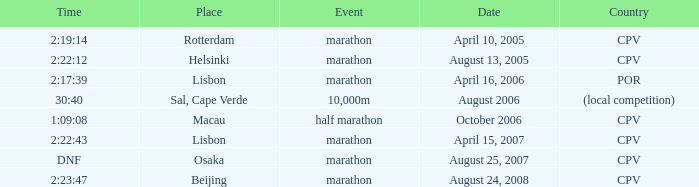Parse the full table. {'header': ['Time', 'Place', 'Event', 'Date', 'Country'], 'rows': [['2:19:14', 'Rotterdam', 'marathon', 'April 10, 2005', 'CPV'], ['2:22:12', 'Helsinki', 'marathon', 'August 13, 2005', 'CPV'], ['2:17:39', 'Lisbon', 'marathon', 'April 16, 2006', 'POR'], ['30:40', 'Sal, Cape Verde', '10,000m', 'August 2006', '(local competition)'], ['1:09:08', 'Macau', 'half marathon', 'October 2006', 'CPV'], ['2:22:43', 'Lisbon', 'marathon', 'April 15, 2007', 'CPV'], ['DNF', 'Osaka', 'marathon', 'August 25, 2007', 'CPV'], ['2:23:47', 'Beijing', 'marathon', 'August 24, 2008', 'CPV']]} What is the Country of the Half Marathon Event? CPV. 